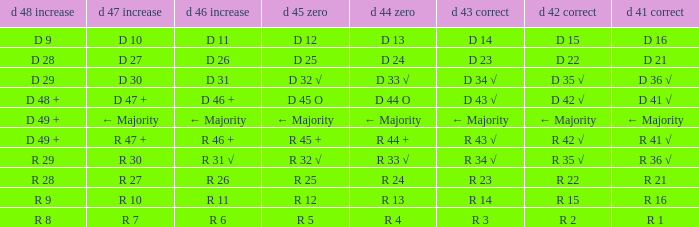What is the value of D 42 √, when the value of D 45 O is d 32 √? D 35 √. 